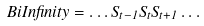<formula> <loc_0><loc_0><loc_500><loc_500>\ B i I n f i n i t y = \dots S _ { t - 1 } S _ { t } S _ { t + 1 } \dots</formula> 